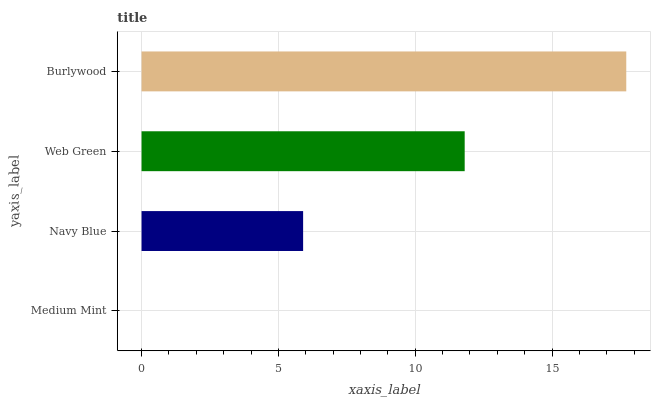Is Medium Mint the minimum?
Answer yes or no. Yes. Is Burlywood the maximum?
Answer yes or no. Yes. Is Navy Blue the minimum?
Answer yes or no. No. Is Navy Blue the maximum?
Answer yes or no. No. Is Navy Blue greater than Medium Mint?
Answer yes or no. Yes. Is Medium Mint less than Navy Blue?
Answer yes or no. Yes. Is Medium Mint greater than Navy Blue?
Answer yes or no. No. Is Navy Blue less than Medium Mint?
Answer yes or no. No. Is Web Green the high median?
Answer yes or no. Yes. Is Navy Blue the low median?
Answer yes or no. Yes. Is Medium Mint the high median?
Answer yes or no. No. Is Web Green the low median?
Answer yes or no. No. 